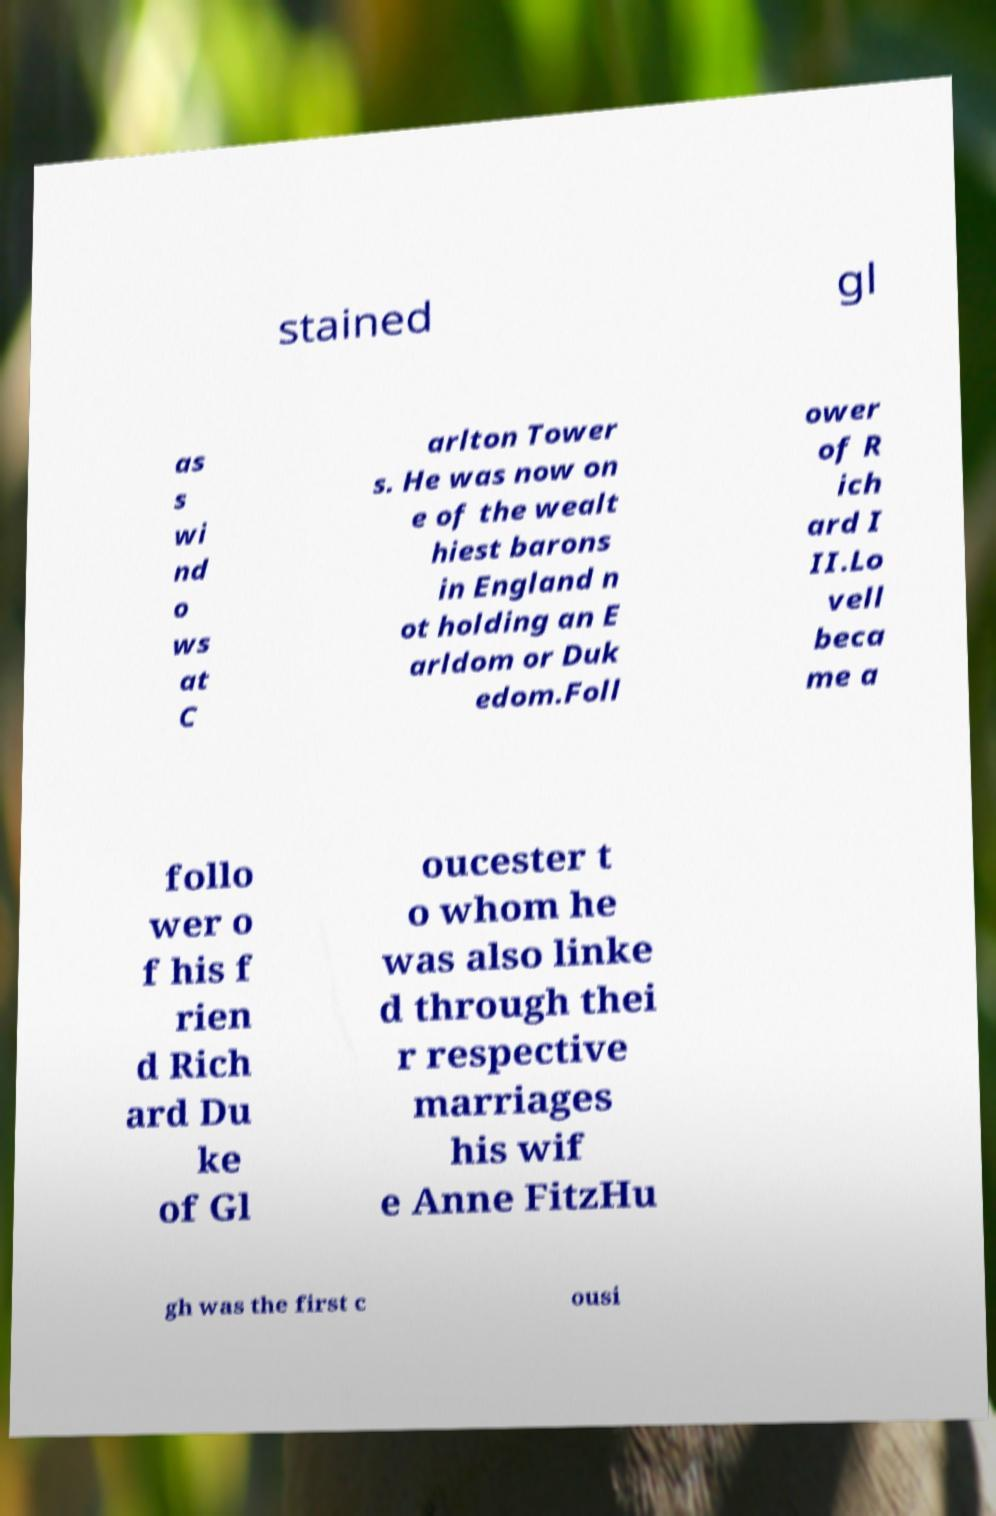Please read and relay the text visible in this image. What does it say? stained gl as s wi nd o ws at C arlton Tower s. He was now on e of the wealt hiest barons in England n ot holding an E arldom or Duk edom.Foll ower of R ich ard I II.Lo vell beca me a follo wer o f his f rien d Rich ard Du ke of Gl oucester t o whom he was also linke d through thei r respective marriages his wif e Anne FitzHu gh was the first c ousi 